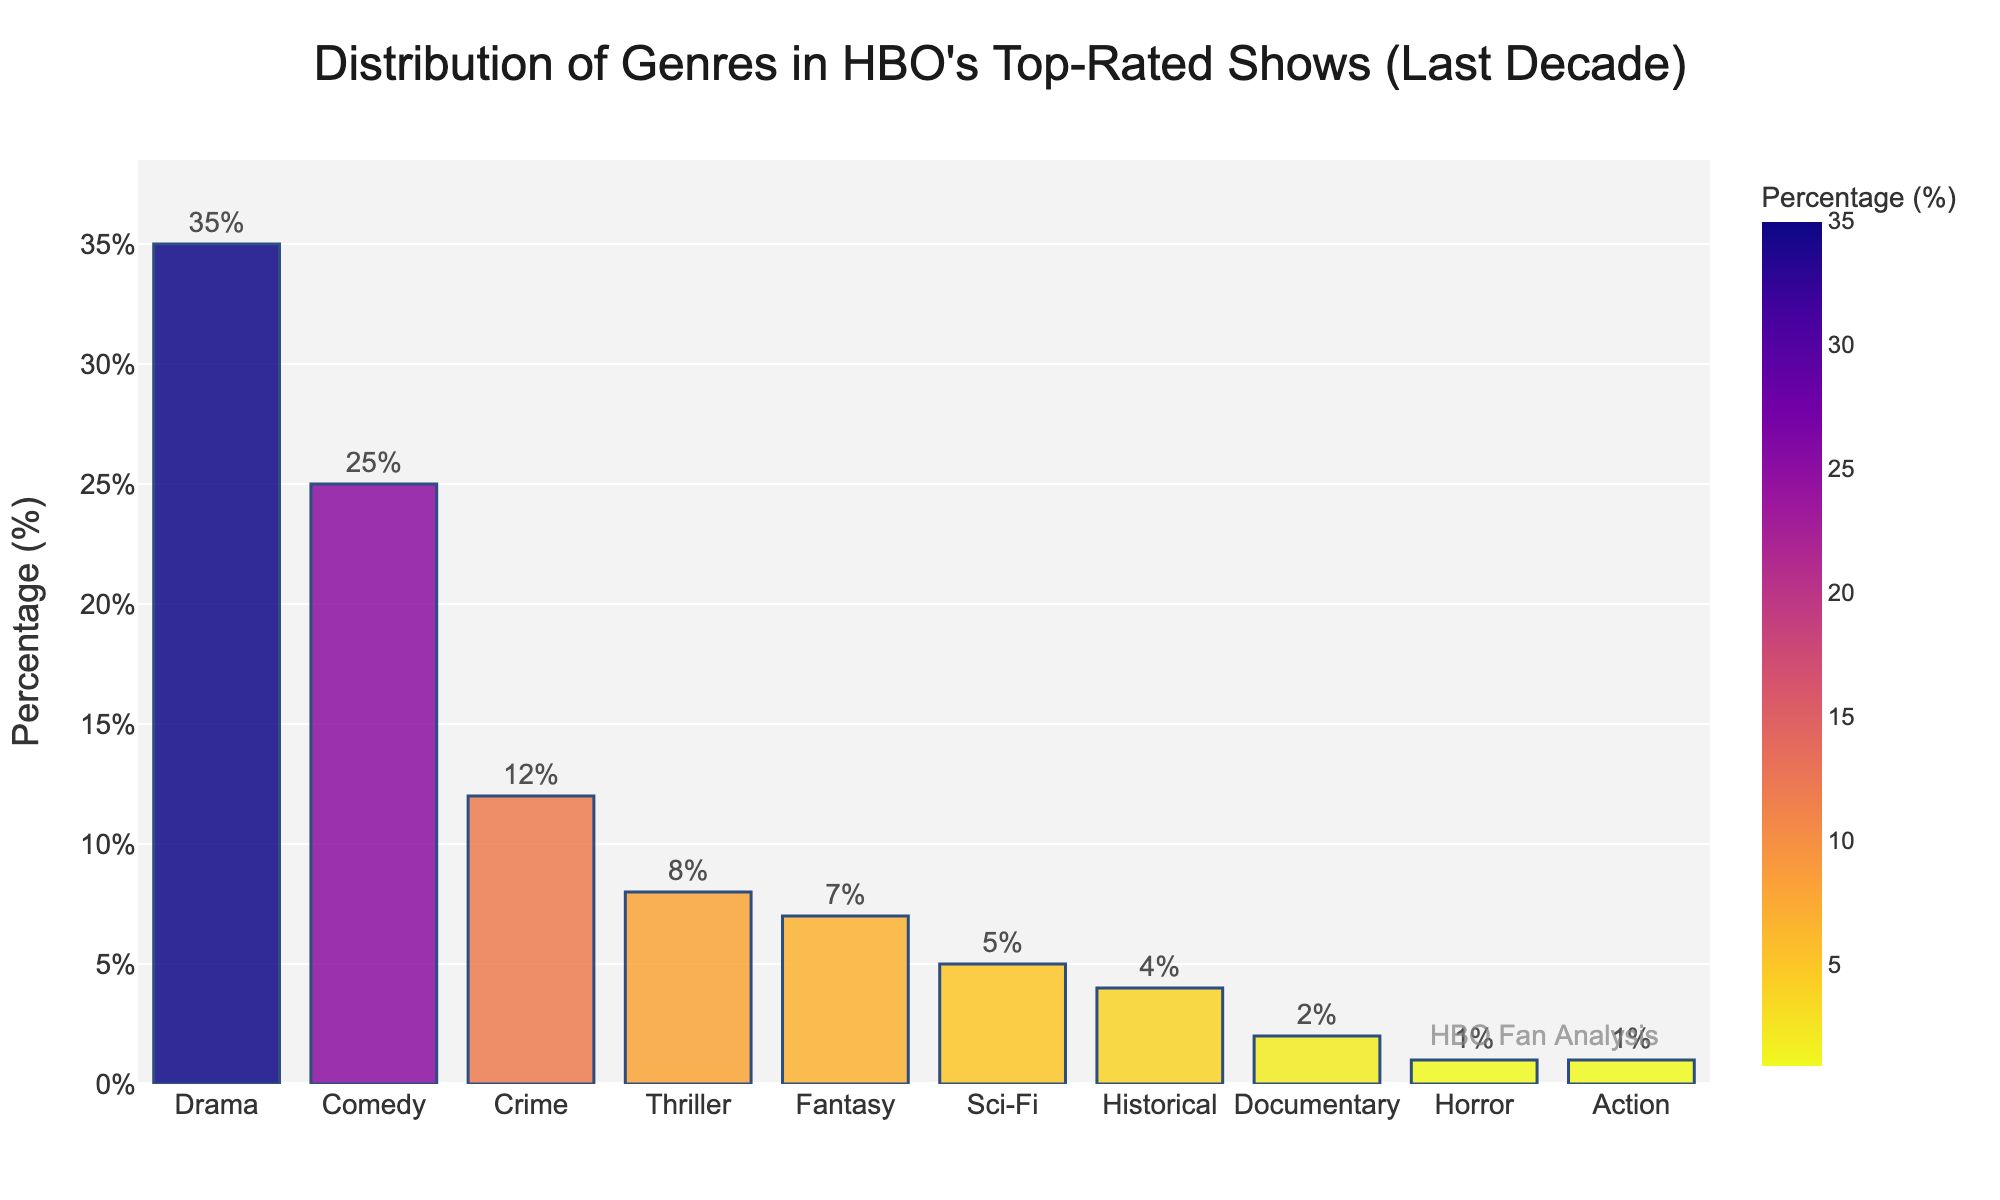What's the most represented genre in HBO's top-rated shows over the past decade? The bar representing Drama shows the highest percentage at 35%, making it the most represented genre.
Answer: Drama How many times more frequent is Drama compared to Horror in HBO's top-rated shows? Drama has a percentage of 35%, while Horror has 1%. Dividing 35 by 1 gives us 35, so Drama is 35 times more frequent than Horror.
Answer: 35 Which genres have a percentage below 5%? Scanning the bar chart, we see that Documentary (2%), Horror (1%), and Action (1%) all have percentages below 5%.
Answer: Documentary, Horror, Action How much more popular is Comedy compared to Action in the top-rated shows? Comedy has a percentage of 25%, while Action sits at 1%. The difference is 25 - 1 = 24%.
Answer: 24% What is the combined percentage of Crime, Thriller, and Fantasy genres? The percentages for Crime, Thriller, and Fantasy are 12%, 8%, and 7%, respectively. Summing these gives 12 + 8 + 7 = 27%.
Answer: 27% Which genre has a higher percentage, Thriller or Sci-Fi? In the figure, Thriller has a percentage of 8%, while Sci-Fi has 5%. Therefore, Thriller has a higher percentage.
Answer: Thriller Are there any genres with equal percentages? Yes, both Horror and Action have equal percentages of 1% in the bar chart.
Answer: Yes What is the visual difference between the bar representing Drama and the bar representing Historical? The bar representing Drama is significantly taller and more vibrant compared to the shorter and less intense bar of Historical, which represents 4%.
Answer: Drama is taller If you sum the percentages of Fantasy, Sci-Fi, Historical, Documentary, and Horror, do you get more than the percentage of Drama? Summing the percentages: Fantasy (7%) + Sci-Fi (5%) + Historical (4%) + Documentary (2%) + Horror (1%) = 19%. This is less than Drama’s 35%.
Answer: No What percentage of HBO's top-rated shows are either Drama or Comedy? Adding the percentages of Drama (35%) and Comedy (25%) gives 35 + 25 = 60%.
Answer: 60% 